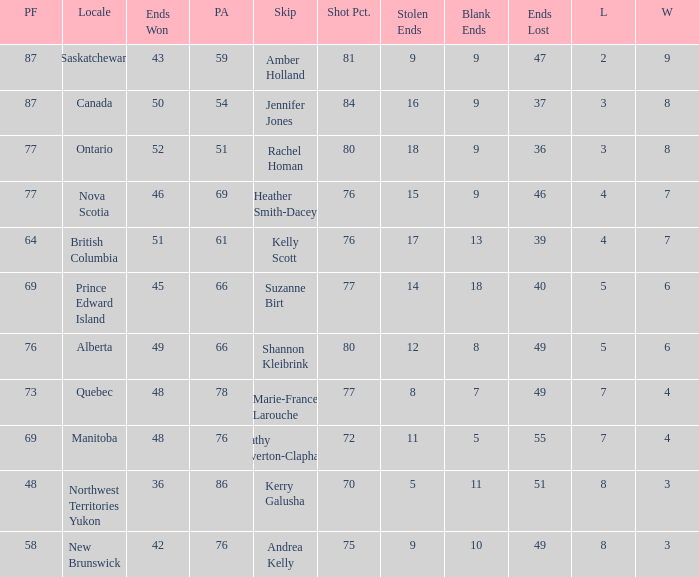If the locale is Ontario, what is the W minimum? 8.0. 